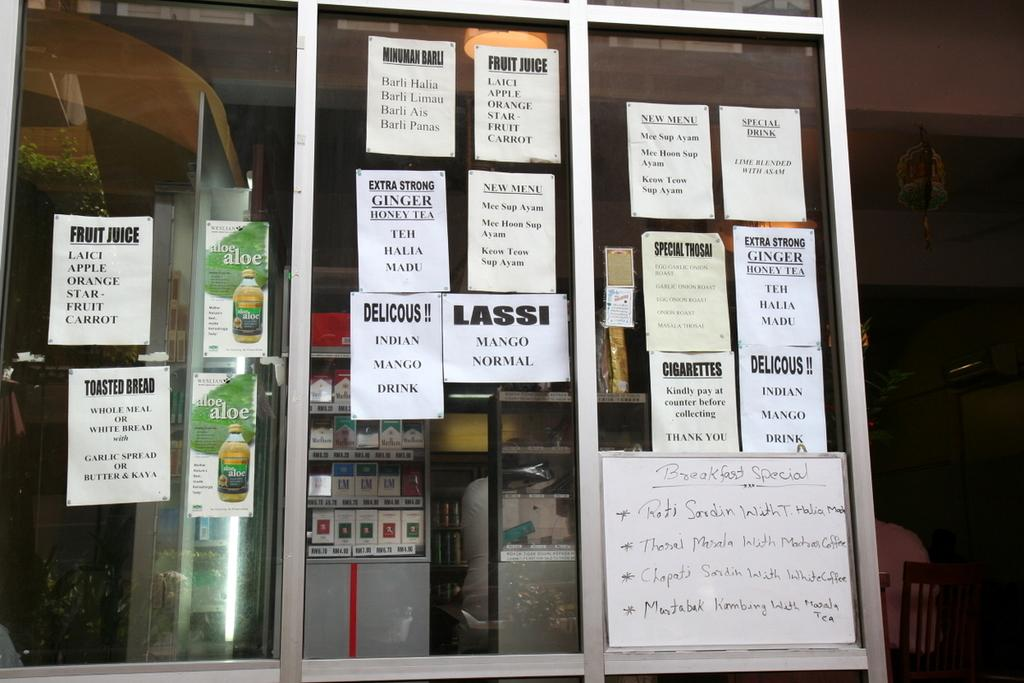<image>
Summarize the visual content of the image. Different pieces of papers tacked to a window advertise teas, juices, and cigarettes. 